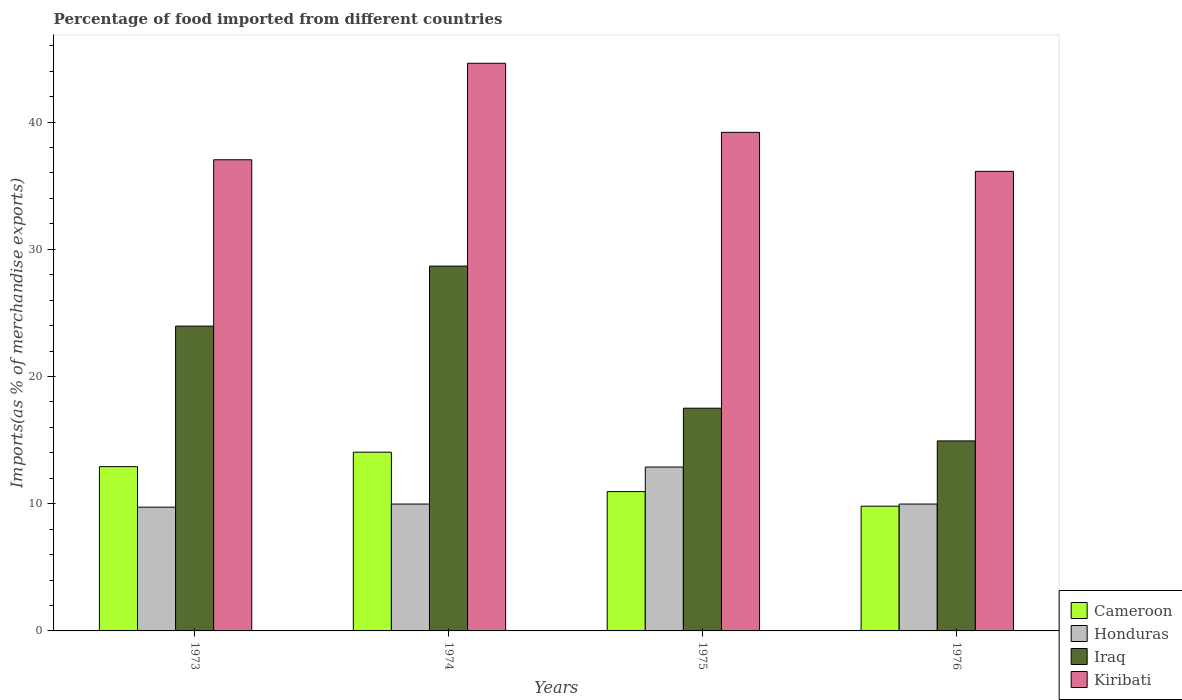How many different coloured bars are there?
Ensure brevity in your answer.  4. How many groups of bars are there?
Provide a succinct answer. 4. Are the number of bars per tick equal to the number of legend labels?
Offer a very short reply. Yes. How many bars are there on the 2nd tick from the left?
Offer a terse response. 4. How many bars are there on the 1st tick from the right?
Your answer should be very brief. 4. What is the label of the 4th group of bars from the left?
Provide a short and direct response. 1976. What is the percentage of imports to different countries in Honduras in 1973?
Your answer should be very brief. 9.73. Across all years, what is the maximum percentage of imports to different countries in Cameroon?
Your answer should be very brief. 14.05. Across all years, what is the minimum percentage of imports to different countries in Honduras?
Keep it short and to the point. 9.73. In which year was the percentage of imports to different countries in Cameroon maximum?
Your response must be concise. 1974. In which year was the percentage of imports to different countries in Honduras minimum?
Your answer should be very brief. 1973. What is the total percentage of imports to different countries in Honduras in the graph?
Offer a terse response. 42.56. What is the difference between the percentage of imports to different countries in Honduras in 1973 and that in 1975?
Offer a terse response. -3.16. What is the difference between the percentage of imports to different countries in Kiribati in 1976 and the percentage of imports to different countries in Honduras in 1974?
Make the answer very short. 26.15. What is the average percentage of imports to different countries in Iraq per year?
Make the answer very short. 21.27. In the year 1976, what is the difference between the percentage of imports to different countries in Honduras and percentage of imports to different countries in Cameroon?
Offer a terse response. 0.17. What is the ratio of the percentage of imports to different countries in Kiribati in 1974 to that in 1976?
Your response must be concise. 1.24. Is the percentage of imports to different countries in Cameroon in 1975 less than that in 1976?
Your answer should be compact. No. What is the difference between the highest and the second highest percentage of imports to different countries in Iraq?
Ensure brevity in your answer.  4.72. What is the difference between the highest and the lowest percentage of imports to different countries in Honduras?
Your answer should be very brief. 3.16. In how many years, is the percentage of imports to different countries in Honduras greater than the average percentage of imports to different countries in Honduras taken over all years?
Offer a terse response. 1. Is it the case that in every year, the sum of the percentage of imports to different countries in Honduras and percentage of imports to different countries in Iraq is greater than the sum of percentage of imports to different countries in Cameroon and percentage of imports to different countries in Kiribati?
Your answer should be very brief. Yes. What does the 1st bar from the left in 1974 represents?
Ensure brevity in your answer.  Cameroon. What does the 3rd bar from the right in 1976 represents?
Your answer should be very brief. Honduras. Is it the case that in every year, the sum of the percentage of imports to different countries in Iraq and percentage of imports to different countries in Cameroon is greater than the percentage of imports to different countries in Honduras?
Ensure brevity in your answer.  Yes. Are all the bars in the graph horizontal?
Offer a terse response. No. Does the graph contain any zero values?
Offer a very short reply. No. How many legend labels are there?
Ensure brevity in your answer.  4. What is the title of the graph?
Make the answer very short. Percentage of food imported from different countries. What is the label or title of the Y-axis?
Offer a very short reply. Imports(as % of merchandise exports). What is the Imports(as % of merchandise exports) in Cameroon in 1973?
Ensure brevity in your answer.  12.91. What is the Imports(as % of merchandise exports) of Honduras in 1973?
Your answer should be very brief. 9.73. What is the Imports(as % of merchandise exports) in Iraq in 1973?
Provide a succinct answer. 23.96. What is the Imports(as % of merchandise exports) of Kiribati in 1973?
Provide a short and direct response. 37.04. What is the Imports(as % of merchandise exports) in Cameroon in 1974?
Provide a short and direct response. 14.05. What is the Imports(as % of merchandise exports) of Honduras in 1974?
Ensure brevity in your answer.  9.97. What is the Imports(as % of merchandise exports) in Iraq in 1974?
Give a very brief answer. 28.68. What is the Imports(as % of merchandise exports) in Kiribati in 1974?
Your answer should be compact. 44.63. What is the Imports(as % of merchandise exports) in Cameroon in 1975?
Make the answer very short. 10.95. What is the Imports(as % of merchandise exports) of Honduras in 1975?
Offer a very short reply. 12.89. What is the Imports(as % of merchandise exports) of Iraq in 1975?
Your answer should be very brief. 17.51. What is the Imports(as % of merchandise exports) in Kiribati in 1975?
Provide a succinct answer. 39.19. What is the Imports(as % of merchandise exports) of Cameroon in 1976?
Offer a terse response. 9.81. What is the Imports(as % of merchandise exports) of Honduras in 1976?
Offer a very short reply. 9.97. What is the Imports(as % of merchandise exports) of Iraq in 1976?
Provide a short and direct response. 14.94. What is the Imports(as % of merchandise exports) of Kiribati in 1976?
Ensure brevity in your answer.  36.13. Across all years, what is the maximum Imports(as % of merchandise exports) of Cameroon?
Give a very brief answer. 14.05. Across all years, what is the maximum Imports(as % of merchandise exports) of Honduras?
Provide a short and direct response. 12.89. Across all years, what is the maximum Imports(as % of merchandise exports) in Iraq?
Give a very brief answer. 28.68. Across all years, what is the maximum Imports(as % of merchandise exports) in Kiribati?
Give a very brief answer. 44.63. Across all years, what is the minimum Imports(as % of merchandise exports) in Cameroon?
Offer a very short reply. 9.81. Across all years, what is the minimum Imports(as % of merchandise exports) of Honduras?
Ensure brevity in your answer.  9.73. Across all years, what is the minimum Imports(as % of merchandise exports) of Iraq?
Provide a short and direct response. 14.94. Across all years, what is the minimum Imports(as % of merchandise exports) in Kiribati?
Make the answer very short. 36.13. What is the total Imports(as % of merchandise exports) in Cameroon in the graph?
Provide a succinct answer. 47.72. What is the total Imports(as % of merchandise exports) in Honduras in the graph?
Provide a short and direct response. 42.56. What is the total Imports(as % of merchandise exports) in Iraq in the graph?
Keep it short and to the point. 85.09. What is the total Imports(as % of merchandise exports) of Kiribati in the graph?
Your answer should be very brief. 156.99. What is the difference between the Imports(as % of merchandise exports) of Cameroon in 1973 and that in 1974?
Offer a very short reply. -1.14. What is the difference between the Imports(as % of merchandise exports) of Honduras in 1973 and that in 1974?
Your response must be concise. -0.25. What is the difference between the Imports(as % of merchandise exports) of Iraq in 1973 and that in 1974?
Give a very brief answer. -4.72. What is the difference between the Imports(as % of merchandise exports) in Kiribati in 1973 and that in 1974?
Provide a succinct answer. -7.59. What is the difference between the Imports(as % of merchandise exports) in Cameroon in 1973 and that in 1975?
Your answer should be compact. 1.96. What is the difference between the Imports(as % of merchandise exports) in Honduras in 1973 and that in 1975?
Your response must be concise. -3.16. What is the difference between the Imports(as % of merchandise exports) in Iraq in 1973 and that in 1975?
Your answer should be very brief. 6.45. What is the difference between the Imports(as % of merchandise exports) in Kiribati in 1973 and that in 1975?
Your answer should be very brief. -2.16. What is the difference between the Imports(as % of merchandise exports) of Cameroon in 1973 and that in 1976?
Ensure brevity in your answer.  3.11. What is the difference between the Imports(as % of merchandise exports) in Honduras in 1973 and that in 1976?
Make the answer very short. -0.25. What is the difference between the Imports(as % of merchandise exports) in Iraq in 1973 and that in 1976?
Make the answer very short. 9.03. What is the difference between the Imports(as % of merchandise exports) of Kiribati in 1973 and that in 1976?
Keep it short and to the point. 0.91. What is the difference between the Imports(as % of merchandise exports) in Cameroon in 1974 and that in 1975?
Keep it short and to the point. 3.1. What is the difference between the Imports(as % of merchandise exports) of Honduras in 1974 and that in 1975?
Make the answer very short. -2.91. What is the difference between the Imports(as % of merchandise exports) in Iraq in 1974 and that in 1975?
Provide a succinct answer. 11.17. What is the difference between the Imports(as % of merchandise exports) in Kiribati in 1974 and that in 1975?
Your answer should be very brief. 5.43. What is the difference between the Imports(as % of merchandise exports) of Cameroon in 1974 and that in 1976?
Keep it short and to the point. 4.24. What is the difference between the Imports(as % of merchandise exports) in Honduras in 1974 and that in 1976?
Make the answer very short. 0. What is the difference between the Imports(as % of merchandise exports) of Iraq in 1974 and that in 1976?
Your answer should be compact. 13.74. What is the difference between the Imports(as % of merchandise exports) of Kiribati in 1974 and that in 1976?
Offer a very short reply. 8.5. What is the difference between the Imports(as % of merchandise exports) of Cameroon in 1975 and that in 1976?
Make the answer very short. 1.14. What is the difference between the Imports(as % of merchandise exports) of Honduras in 1975 and that in 1976?
Make the answer very short. 2.91. What is the difference between the Imports(as % of merchandise exports) in Iraq in 1975 and that in 1976?
Offer a terse response. 2.57. What is the difference between the Imports(as % of merchandise exports) of Kiribati in 1975 and that in 1976?
Your answer should be very brief. 3.07. What is the difference between the Imports(as % of merchandise exports) of Cameroon in 1973 and the Imports(as % of merchandise exports) of Honduras in 1974?
Give a very brief answer. 2.94. What is the difference between the Imports(as % of merchandise exports) in Cameroon in 1973 and the Imports(as % of merchandise exports) in Iraq in 1974?
Your answer should be very brief. -15.77. What is the difference between the Imports(as % of merchandise exports) in Cameroon in 1973 and the Imports(as % of merchandise exports) in Kiribati in 1974?
Offer a very short reply. -31.71. What is the difference between the Imports(as % of merchandise exports) of Honduras in 1973 and the Imports(as % of merchandise exports) of Iraq in 1974?
Offer a terse response. -18.95. What is the difference between the Imports(as % of merchandise exports) in Honduras in 1973 and the Imports(as % of merchandise exports) in Kiribati in 1974?
Give a very brief answer. -34.9. What is the difference between the Imports(as % of merchandise exports) of Iraq in 1973 and the Imports(as % of merchandise exports) of Kiribati in 1974?
Your response must be concise. -20.66. What is the difference between the Imports(as % of merchandise exports) of Cameroon in 1973 and the Imports(as % of merchandise exports) of Honduras in 1975?
Your response must be concise. 0.03. What is the difference between the Imports(as % of merchandise exports) of Cameroon in 1973 and the Imports(as % of merchandise exports) of Iraq in 1975?
Provide a succinct answer. -4.6. What is the difference between the Imports(as % of merchandise exports) in Cameroon in 1973 and the Imports(as % of merchandise exports) in Kiribati in 1975?
Give a very brief answer. -26.28. What is the difference between the Imports(as % of merchandise exports) in Honduras in 1973 and the Imports(as % of merchandise exports) in Iraq in 1975?
Your answer should be very brief. -7.78. What is the difference between the Imports(as % of merchandise exports) in Honduras in 1973 and the Imports(as % of merchandise exports) in Kiribati in 1975?
Give a very brief answer. -29.47. What is the difference between the Imports(as % of merchandise exports) in Iraq in 1973 and the Imports(as % of merchandise exports) in Kiribati in 1975?
Make the answer very short. -15.23. What is the difference between the Imports(as % of merchandise exports) in Cameroon in 1973 and the Imports(as % of merchandise exports) in Honduras in 1976?
Your answer should be compact. 2.94. What is the difference between the Imports(as % of merchandise exports) in Cameroon in 1973 and the Imports(as % of merchandise exports) in Iraq in 1976?
Ensure brevity in your answer.  -2.02. What is the difference between the Imports(as % of merchandise exports) of Cameroon in 1973 and the Imports(as % of merchandise exports) of Kiribati in 1976?
Give a very brief answer. -23.21. What is the difference between the Imports(as % of merchandise exports) in Honduras in 1973 and the Imports(as % of merchandise exports) in Iraq in 1976?
Your answer should be very brief. -5.21. What is the difference between the Imports(as % of merchandise exports) in Honduras in 1973 and the Imports(as % of merchandise exports) in Kiribati in 1976?
Ensure brevity in your answer.  -26.4. What is the difference between the Imports(as % of merchandise exports) of Iraq in 1973 and the Imports(as % of merchandise exports) of Kiribati in 1976?
Provide a short and direct response. -12.16. What is the difference between the Imports(as % of merchandise exports) in Cameroon in 1974 and the Imports(as % of merchandise exports) in Honduras in 1975?
Your answer should be very brief. 1.17. What is the difference between the Imports(as % of merchandise exports) in Cameroon in 1974 and the Imports(as % of merchandise exports) in Iraq in 1975?
Provide a succinct answer. -3.46. What is the difference between the Imports(as % of merchandise exports) of Cameroon in 1974 and the Imports(as % of merchandise exports) of Kiribati in 1975?
Provide a short and direct response. -25.14. What is the difference between the Imports(as % of merchandise exports) in Honduras in 1974 and the Imports(as % of merchandise exports) in Iraq in 1975?
Keep it short and to the point. -7.53. What is the difference between the Imports(as % of merchandise exports) in Honduras in 1974 and the Imports(as % of merchandise exports) in Kiribati in 1975?
Give a very brief answer. -29.22. What is the difference between the Imports(as % of merchandise exports) in Iraq in 1974 and the Imports(as % of merchandise exports) in Kiribati in 1975?
Keep it short and to the point. -10.51. What is the difference between the Imports(as % of merchandise exports) of Cameroon in 1974 and the Imports(as % of merchandise exports) of Honduras in 1976?
Ensure brevity in your answer.  4.08. What is the difference between the Imports(as % of merchandise exports) of Cameroon in 1974 and the Imports(as % of merchandise exports) of Iraq in 1976?
Offer a terse response. -0.89. What is the difference between the Imports(as % of merchandise exports) of Cameroon in 1974 and the Imports(as % of merchandise exports) of Kiribati in 1976?
Offer a very short reply. -22.08. What is the difference between the Imports(as % of merchandise exports) of Honduras in 1974 and the Imports(as % of merchandise exports) of Iraq in 1976?
Offer a terse response. -4.96. What is the difference between the Imports(as % of merchandise exports) of Honduras in 1974 and the Imports(as % of merchandise exports) of Kiribati in 1976?
Offer a terse response. -26.15. What is the difference between the Imports(as % of merchandise exports) in Iraq in 1974 and the Imports(as % of merchandise exports) in Kiribati in 1976?
Your answer should be compact. -7.45. What is the difference between the Imports(as % of merchandise exports) in Cameroon in 1975 and the Imports(as % of merchandise exports) in Honduras in 1976?
Offer a very short reply. 0.98. What is the difference between the Imports(as % of merchandise exports) of Cameroon in 1975 and the Imports(as % of merchandise exports) of Iraq in 1976?
Offer a very short reply. -3.99. What is the difference between the Imports(as % of merchandise exports) of Cameroon in 1975 and the Imports(as % of merchandise exports) of Kiribati in 1976?
Offer a terse response. -25.18. What is the difference between the Imports(as % of merchandise exports) of Honduras in 1975 and the Imports(as % of merchandise exports) of Iraq in 1976?
Give a very brief answer. -2.05. What is the difference between the Imports(as % of merchandise exports) of Honduras in 1975 and the Imports(as % of merchandise exports) of Kiribati in 1976?
Make the answer very short. -23.24. What is the difference between the Imports(as % of merchandise exports) in Iraq in 1975 and the Imports(as % of merchandise exports) in Kiribati in 1976?
Your answer should be compact. -18.62. What is the average Imports(as % of merchandise exports) of Cameroon per year?
Your answer should be compact. 11.93. What is the average Imports(as % of merchandise exports) of Honduras per year?
Make the answer very short. 10.64. What is the average Imports(as % of merchandise exports) in Iraq per year?
Offer a very short reply. 21.27. What is the average Imports(as % of merchandise exports) in Kiribati per year?
Give a very brief answer. 39.25. In the year 1973, what is the difference between the Imports(as % of merchandise exports) of Cameroon and Imports(as % of merchandise exports) of Honduras?
Your answer should be compact. 3.18. In the year 1973, what is the difference between the Imports(as % of merchandise exports) of Cameroon and Imports(as % of merchandise exports) of Iraq?
Make the answer very short. -11.05. In the year 1973, what is the difference between the Imports(as % of merchandise exports) of Cameroon and Imports(as % of merchandise exports) of Kiribati?
Your answer should be very brief. -24.13. In the year 1973, what is the difference between the Imports(as % of merchandise exports) of Honduras and Imports(as % of merchandise exports) of Iraq?
Your answer should be very brief. -14.23. In the year 1973, what is the difference between the Imports(as % of merchandise exports) in Honduras and Imports(as % of merchandise exports) in Kiribati?
Give a very brief answer. -27.31. In the year 1973, what is the difference between the Imports(as % of merchandise exports) in Iraq and Imports(as % of merchandise exports) in Kiribati?
Your answer should be very brief. -13.08. In the year 1974, what is the difference between the Imports(as % of merchandise exports) of Cameroon and Imports(as % of merchandise exports) of Honduras?
Offer a terse response. 4.08. In the year 1974, what is the difference between the Imports(as % of merchandise exports) of Cameroon and Imports(as % of merchandise exports) of Iraq?
Your answer should be compact. -14.63. In the year 1974, what is the difference between the Imports(as % of merchandise exports) in Cameroon and Imports(as % of merchandise exports) in Kiribati?
Give a very brief answer. -30.57. In the year 1974, what is the difference between the Imports(as % of merchandise exports) of Honduras and Imports(as % of merchandise exports) of Iraq?
Provide a short and direct response. -18.71. In the year 1974, what is the difference between the Imports(as % of merchandise exports) in Honduras and Imports(as % of merchandise exports) in Kiribati?
Your response must be concise. -34.65. In the year 1974, what is the difference between the Imports(as % of merchandise exports) of Iraq and Imports(as % of merchandise exports) of Kiribati?
Your answer should be compact. -15.95. In the year 1975, what is the difference between the Imports(as % of merchandise exports) in Cameroon and Imports(as % of merchandise exports) in Honduras?
Ensure brevity in your answer.  -1.93. In the year 1975, what is the difference between the Imports(as % of merchandise exports) of Cameroon and Imports(as % of merchandise exports) of Iraq?
Give a very brief answer. -6.56. In the year 1975, what is the difference between the Imports(as % of merchandise exports) in Cameroon and Imports(as % of merchandise exports) in Kiribati?
Offer a very short reply. -28.24. In the year 1975, what is the difference between the Imports(as % of merchandise exports) of Honduras and Imports(as % of merchandise exports) of Iraq?
Offer a very short reply. -4.62. In the year 1975, what is the difference between the Imports(as % of merchandise exports) of Honduras and Imports(as % of merchandise exports) of Kiribati?
Make the answer very short. -26.31. In the year 1975, what is the difference between the Imports(as % of merchandise exports) of Iraq and Imports(as % of merchandise exports) of Kiribati?
Keep it short and to the point. -21.69. In the year 1976, what is the difference between the Imports(as % of merchandise exports) of Cameroon and Imports(as % of merchandise exports) of Honduras?
Your answer should be very brief. -0.17. In the year 1976, what is the difference between the Imports(as % of merchandise exports) in Cameroon and Imports(as % of merchandise exports) in Iraq?
Your answer should be compact. -5.13. In the year 1976, what is the difference between the Imports(as % of merchandise exports) in Cameroon and Imports(as % of merchandise exports) in Kiribati?
Your answer should be compact. -26.32. In the year 1976, what is the difference between the Imports(as % of merchandise exports) in Honduras and Imports(as % of merchandise exports) in Iraq?
Make the answer very short. -4.96. In the year 1976, what is the difference between the Imports(as % of merchandise exports) of Honduras and Imports(as % of merchandise exports) of Kiribati?
Ensure brevity in your answer.  -26.15. In the year 1976, what is the difference between the Imports(as % of merchandise exports) in Iraq and Imports(as % of merchandise exports) in Kiribati?
Offer a very short reply. -21.19. What is the ratio of the Imports(as % of merchandise exports) in Cameroon in 1973 to that in 1974?
Keep it short and to the point. 0.92. What is the ratio of the Imports(as % of merchandise exports) of Honduras in 1973 to that in 1974?
Ensure brevity in your answer.  0.98. What is the ratio of the Imports(as % of merchandise exports) in Iraq in 1973 to that in 1974?
Your response must be concise. 0.84. What is the ratio of the Imports(as % of merchandise exports) in Kiribati in 1973 to that in 1974?
Give a very brief answer. 0.83. What is the ratio of the Imports(as % of merchandise exports) in Cameroon in 1973 to that in 1975?
Ensure brevity in your answer.  1.18. What is the ratio of the Imports(as % of merchandise exports) in Honduras in 1973 to that in 1975?
Ensure brevity in your answer.  0.76. What is the ratio of the Imports(as % of merchandise exports) in Iraq in 1973 to that in 1975?
Ensure brevity in your answer.  1.37. What is the ratio of the Imports(as % of merchandise exports) in Kiribati in 1973 to that in 1975?
Ensure brevity in your answer.  0.94. What is the ratio of the Imports(as % of merchandise exports) in Cameroon in 1973 to that in 1976?
Offer a very short reply. 1.32. What is the ratio of the Imports(as % of merchandise exports) in Honduras in 1973 to that in 1976?
Keep it short and to the point. 0.98. What is the ratio of the Imports(as % of merchandise exports) in Iraq in 1973 to that in 1976?
Offer a very short reply. 1.6. What is the ratio of the Imports(as % of merchandise exports) in Kiribati in 1973 to that in 1976?
Your response must be concise. 1.03. What is the ratio of the Imports(as % of merchandise exports) of Cameroon in 1974 to that in 1975?
Provide a short and direct response. 1.28. What is the ratio of the Imports(as % of merchandise exports) in Honduras in 1974 to that in 1975?
Your answer should be compact. 0.77. What is the ratio of the Imports(as % of merchandise exports) of Iraq in 1974 to that in 1975?
Your answer should be very brief. 1.64. What is the ratio of the Imports(as % of merchandise exports) in Kiribati in 1974 to that in 1975?
Offer a very short reply. 1.14. What is the ratio of the Imports(as % of merchandise exports) in Cameroon in 1974 to that in 1976?
Your response must be concise. 1.43. What is the ratio of the Imports(as % of merchandise exports) of Iraq in 1974 to that in 1976?
Provide a short and direct response. 1.92. What is the ratio of the Imports(as % of merchandise exports) of Kiribati in 1974 to that in 1976?
Your response must be concise. 1.24. What is the ratio of the Imports(as % of merchandise exports) of Cameroon in 1975 to that in 1976?
Ensure brevity in your answer.  1.12. What is the ratio of the Imports(as % of merchandise exports) of Honduras in 1975 to that in 1976?
Offer a very short reply. 1.29. What is the ratio of the Imports(as % of merchandise exports) in Iraq in 1975 to that in 1976?
Your answer should be compact. 1.17. What is the ratio of the Imports(as % of merchandise exports) of Kiribati in 1975 to that in 1976?
Give a very brief answer. 1.08. What is the difference between the highest and the second highest Imports(as % of merchandise exports) of Cameroon?
Give a very brief answer. 1.14. What is the difference between the highest and the second highest Imports(as % of merchandise exports) in Honduras?
Keep it short and to the point. 2.91. What is the difference between the highest and the second highest Imports(as % of merchandise exports) in Iraq?
Offer a very short reply. 4.72. What is the difference between the highest and the second highest Imports(as % of merchandise exports) in Kiribati?
Your answer should be compact. 5.43. What is the difference between the highest and the lowest Imports(as % of merchandise exports) of Cameroon?
Your response must be concise. 4.24. What is the difference between the highest and the lowest Imports(as % of merchandise exports) of Honduras?
Provide a short and direct response. 3.16. What is the difference between the highest and the lowest Imports(as % of merchandise exports) in Iraq?
Keep it short and to the point. 13.74. What is the difference between the highest and the lowest Imports(as % of merchandise exports) in Kiribati?
Your answer should be compact. 8.5. 